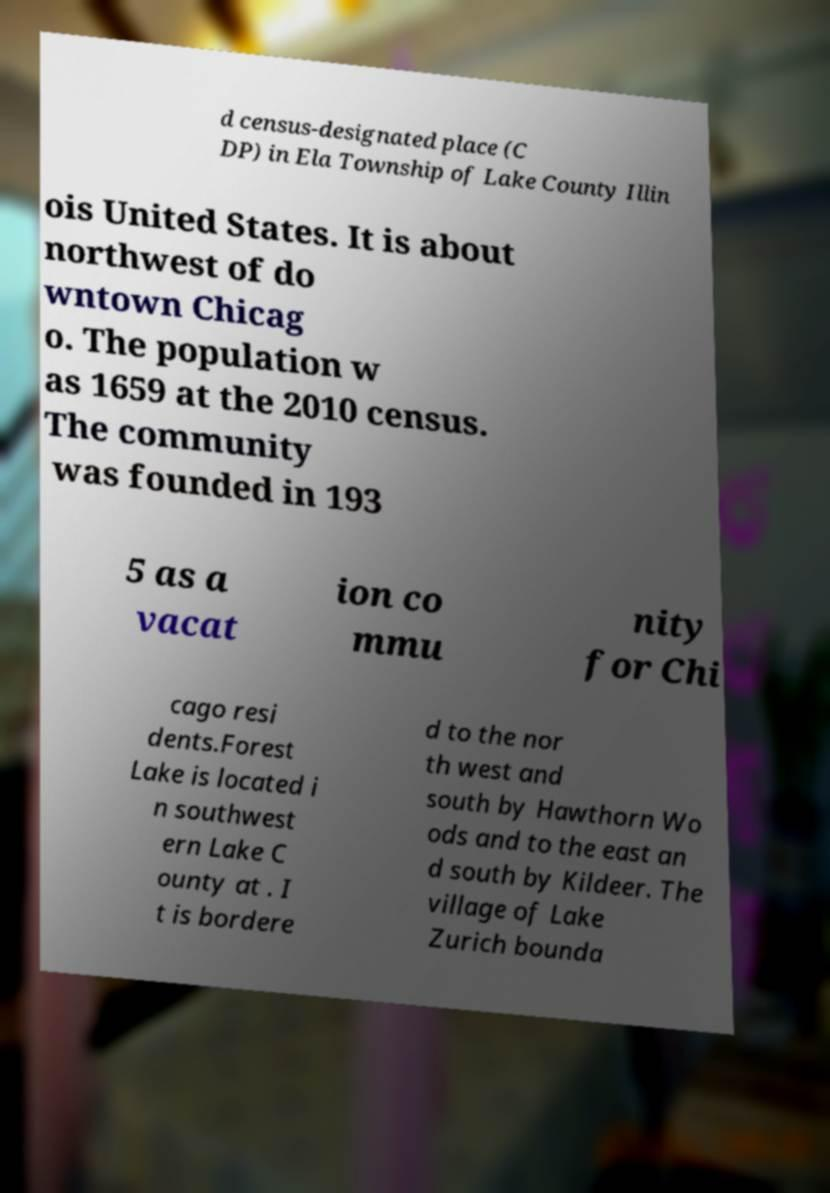For documentation purposes, I need the text within this image transcribed. Could you provide that? d census-designated place (C DP) in Ela Township of Lake County Illin ois United States. It is about northwest of do wntown Chicag o. The population w as 1659 at the 2010 census. The community was founded in 193 5 as a vacat ion co mmu nity for Chi cago resi dents.Forest Lake is located i n southwest ern Lake C ounty at . I t is bordere d to the nor th west and south by Hawthorn Wo ods and to the east an d south by Kildeer. The village of Lake Zurich bounda 